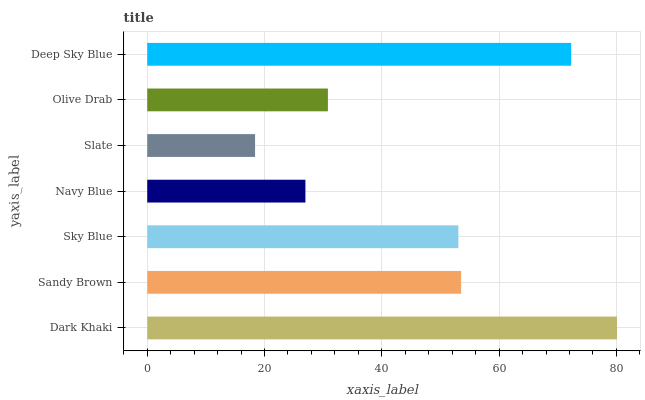Is Slate the minimum?
Answer yes or no. Yes. Is Dark Khaki the maximum?
Answer yes or no. Yes. Is Sandy Brown the minimum?
Answer yes or no. No. Is Sandy Brown the maximum?
Answer yes or no. No. Is Dark Khaki greater than Sandy Brown?
Answer yes or no. Yes. Is Sandy Brown less than Dark Khaki?
Answer yes or no. Yes. Is Sandy Brown greater than Dark Khaki?
Answer yes or no. No. Is Dark Khaki less than Sandy Brown?
Answer yes or no. No. Is Sky Blue the high median?
Answer yes or no. Yes. Is Sky Blue the low median?
Answer yes or no. Yes. Is Dark Khaki the high median?
Answer yes or no. No. Is Slate the low median?
Answer yes or no. No. 